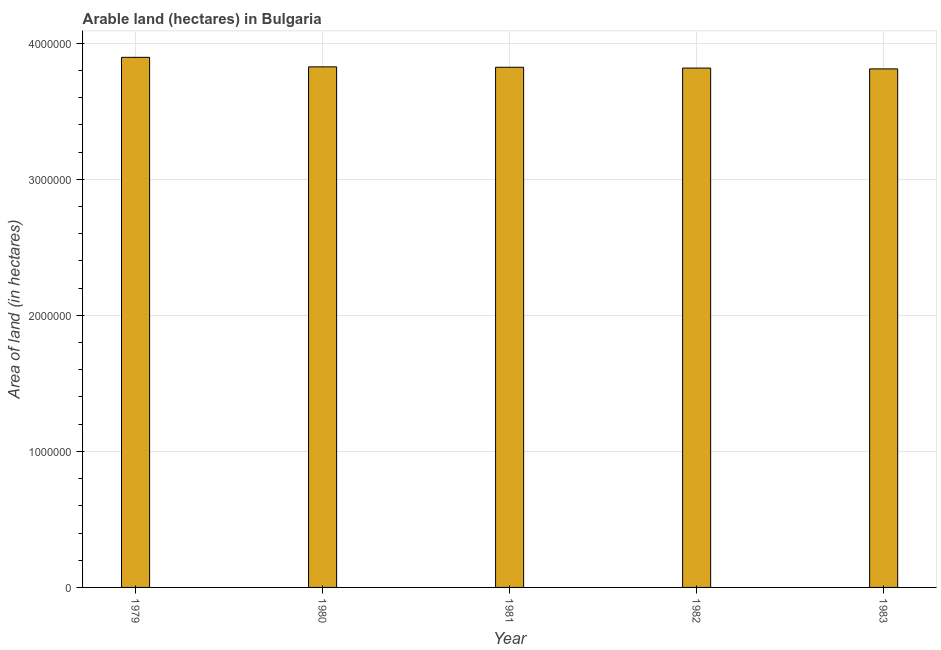Does the graph contain any zero values?
Your answer should be very brief. No. What is the title of the graph?
Give a very brief answer. Arable land (hectares) in Bulgaria. What is the label or title of the X-axis?
Provide a short and direct response. Year. What is the label or title of the Y-axis?
Keep it short and to the point. Area of land (in hectares). What is the area of land in 1983?
Provide a succinct answer. 3.81e+06. Across all years, what is the maximum area of land?
Your answer should be compact. 3.90e+06. Across all years, what is the minimum area of land?
Offer a very short reply. 3.81e+06. In which year was the area of land maximum?
Your response must be concise. 1979. In which year was the area of land minimum?
Keep it short and to the point. 1983. What is the sum of the area of land?
Give a very brief answer. 1.92e+07. What is the difference between the area of land in 1982 and 1983?
Provide a succinct answer. 6000. What is the average area of land per year?
Offer a very short reply. 3.84e+06. What is the median area of land?
Keep it short and to the point. 3.82e+06. Is the area of land in 1982 less than that in 1983?
Ensure brevity in your answer.  No. What is the difference between the highest and the second highest area of land?
Keep it short and to the point. 7.00e+04. What is the difference between the highest and the lowest area of land?
Provide a succinct answer. 8.50e+04. In how many years, is the area of land greater than the average area of land taken over all years?
Offer a terse response. 1. How many bars are there?
Give a very brief answer. 5. How many years are there in the graph?
Your response must be concise. 5. What is the difference between two consecutive major ticks on the Y-axis?
Make the answer very short. 1.00e+06. What is the Area of land (in hectares) in 1979?
Make the answer very short. 3.90e+06. What is the Area of land (in hectares) in 1980?
Provide a succinct answer. 3.83e+06. What is the Area of land (in hectares) in 1981?
Provide a short and direct response. 3.82e+06. What is the Area of land (in hectares) of 1982?
Provide a short and direct response. 3.82e+06. What is the Area of land (in hectares) in 1983?
Provide a short and direct response. 3.81e+06. What is the difference between the Area of land (in hectares) in 1979 and 1981?
Provide a short and direct response. 7.30e+04. What is the difference between the Area of land (in hectares) in 1979 and 1982?
Your answer should be very brief. 7.90e+04. What is the difference between the Area of land (in hectares) in 1979 and 1983?
Your response must be concise. 8.50e+04. What is the difference between the Area of land (in hectares) in 1980 and 1981?
Your answer should be compact. 3000. What is the difference between the Area of land (in hectares) in 1980 and 1982?
Provide a succinct answer. 9000. What is the difference between the Area of land (in hectares) in 1980 and 1983?
Make the answer very short. 1.50e+04. What is the difference between the Area of land (in hectares) in 1981 and 1982?
Your response must be concise. 6000. What is the difference between the Area of land (in hectares) in 1981 and 1983?
Make the answer very short. 1.20e+04. What is the difference between the Area of land (in hectares) in 1982 and 1983?
Give a very brief answer. 6000. What is the ratio of the Area of land (in hectares) in 1979 to that in 1980?
Give a very brief answer. 1.02. What is the ratio of the Area of land (in hectares) in 1979 to that in 1981?
Give a very brief answer. 1.02. What is the ratio of the Area of land (in hectares) in 1980 to that in 1981?
Make the answer very short. 1. What is the ratio of the Area of land (in hectares) in 1980 to that in 1982?
Keep it short and to the point. 1. What is the ratio of the Area of land (in hectares) in 1980 to that in 1983?
Your answer should be very brief. 1. What is the ratio of the Area of land (in hectares) in 1981 to that in 1982?
Make the answer very short. 1. What is the ratio of the Area of land (in hectares) in 1982 to that in 1983?
Keep it short and to the point. 1. 